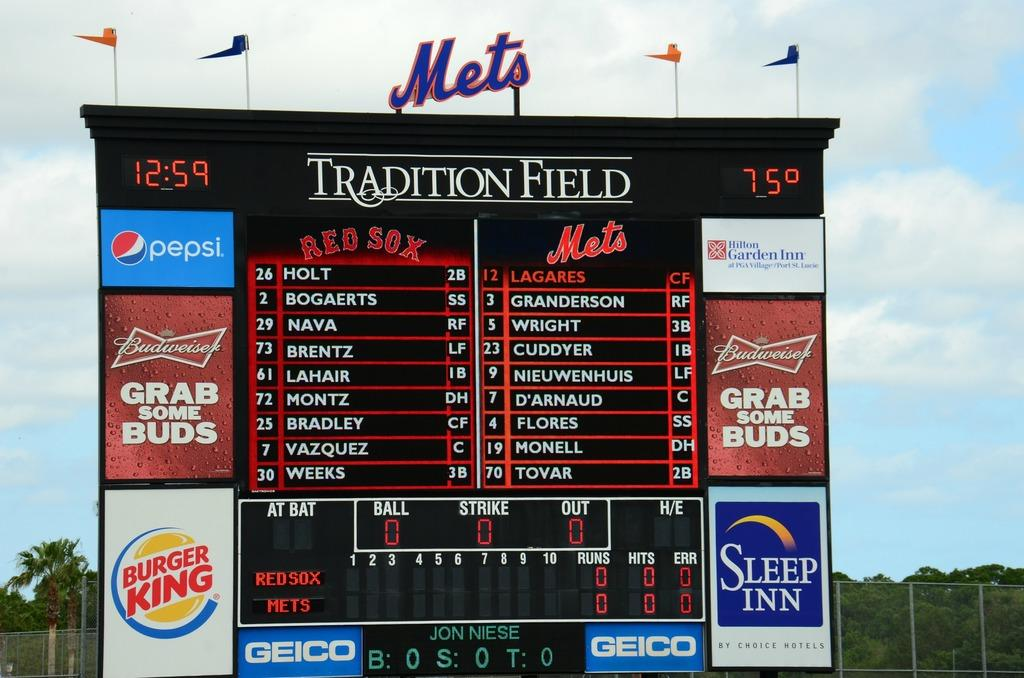<image>
Render a clear and concise summary of the photo. The scoreboard at the Mets stadium shows the score betweed the Red Sox and Mets. 